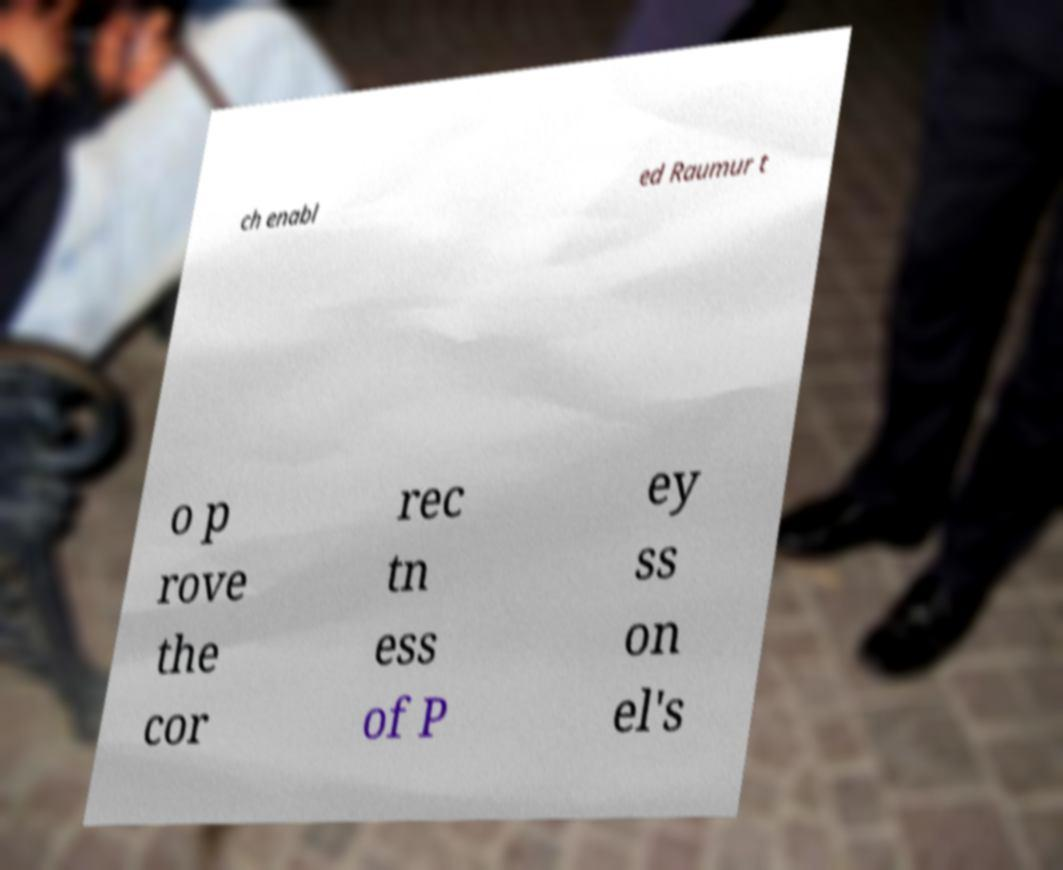What messages or text are displayed in this image? I need them in a readable, typed format. ch enabl ed Raumur t o p rove the cor rec tn ess of P ey ss on el's 